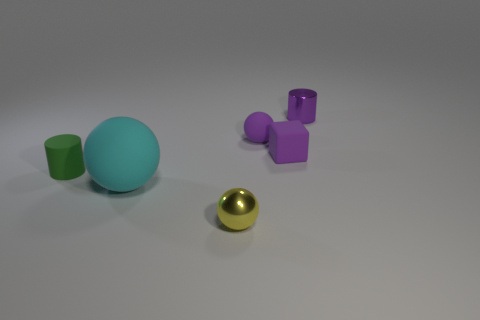What is the material of the cylinder left of the cylinder that is right of the large cyan rubber sphere?
Your answer should be very brief. Rubber. Are there fewer large cyan balls behind the matte cylinder than tiny rubber cylinders behind the rubber cube?
Provide a short and direct response. No. There is a sphere that is the same color as the tiny block; what is its material?
Provide a short and direct response. Rubber. Is there any other thing that is the same shape as the large matte thing?
Keep it short and to the point. Yes. There is a small ball in front of the tiny rubber cube; what is its material?
Your answer should be compact. Metal. Is there anything else that is the same size as the cyan sphere?
Provide a succinct answer. No. There is a tiny yellow thing; are there any large cyan matte things right of it?
Your answer should be compact. No. What is the shape of the purple metal thing?
Your answer should be very brief. Cylinder. How many objects are purple matte objects in front of the tiny matte sphere or blue matte spheres?
Your response must be concise. 1. How many other objects are the same color as the tiny matte cylinder?
Provide a short and direct response. 0. 